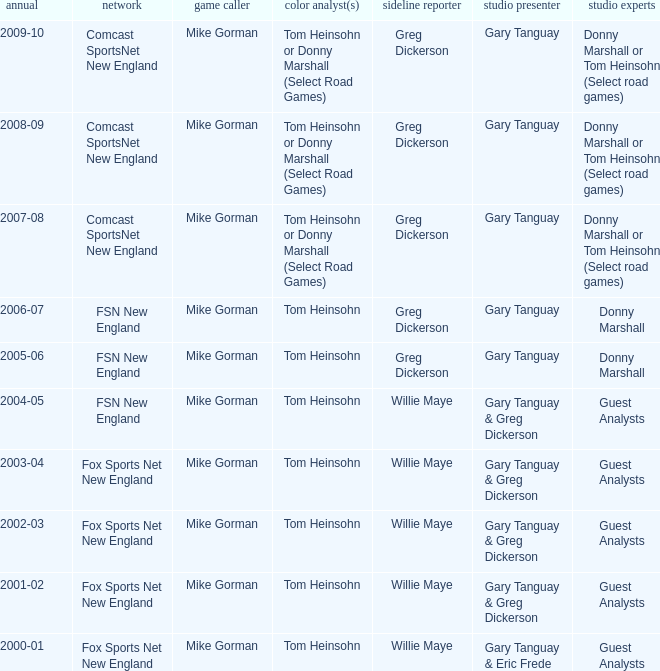Which Courtside reporter has a Channel of fsn new england in 2006-07? Greg Dickerson. 